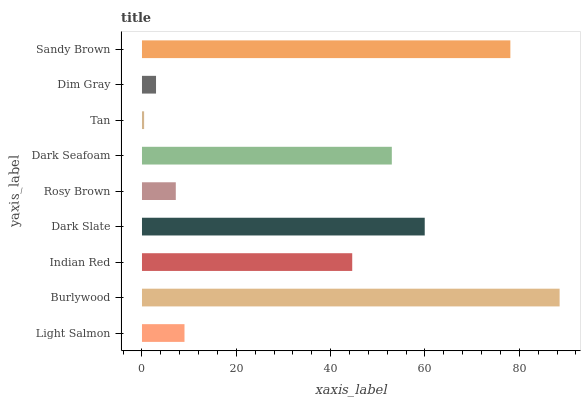Is Tan the minimum?
Answer yes or no. Yes. Is Burlywood the maximum?
Answer yes or no. Yes. Is Indian Red the minimum?
Answer yes or no. No. Is Indian Red the maximum?
Answer yes or no. No. Is Burlywood greater than Indian Red?
Answer yes or no. Yes. Is Indian Red less than Burlywood?
Answer yes or no. Yes. Is Indian Red greater than Burlywood?
Answer yes or no. No. Is Burlywood less than Indian Red?
Answer yes or no. No. Is Indian Red the high median?
Answer yes or no. Yes. Is Indian Red the low median?
Answer yes or no. Yes. Is Tan the high median?
Answer yes or no. No. Is Dark Seafoam the low median?
Answer yes or no. No. 